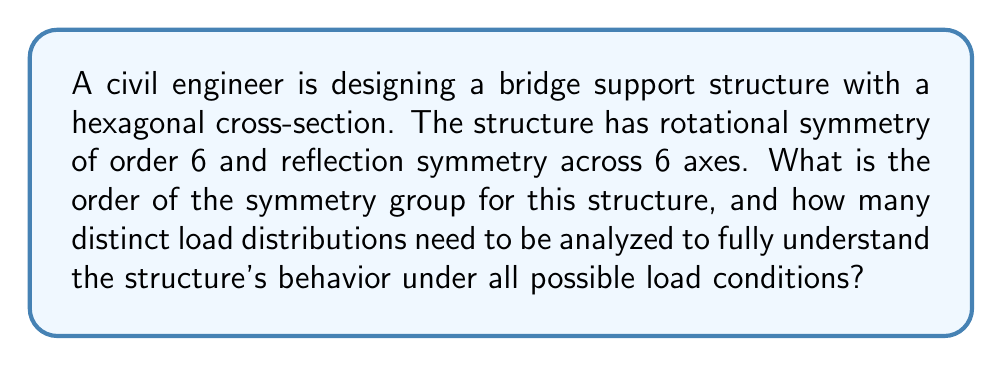Show me your answer to this math problem. To solve this problem, we need to understand the concept of symmetry groups and their application in structural design.

1. Identify the symmetry elements:
   - Rotational symmetry of order 6 (rotations by 60°, 120°, 180°, 240°, 300°, and 360°)
   - 6 reflection axes

2. Determine the symmetry group:
   The symmetry group of a regular hexagon is the dihedral group $D_6$.

3. Calculate the order of the symmetry group:
   The order of $D_6$ is given by the formula:
   $$|D_6| = 2n = 2 \cdot 6 = 12$$
   where $n$ is the number of sides of the polygon.

4. Analyze distinct load distributions:
   The number of distinct load distributions is equal to the number of symmetry classes, which can be calculated using Burnside's lemma:

   $$N = \frac{1}{|G|} \sum_{g \in G} |X^g|$$

   where:
   $N$ is the number of symmetry classes
   $|G|$ is the order of the symmetry group
   $X^g$ is the set of elements fixed by the symmetry operation $g$

5. Apply Burnside's lemma:
   - Identity element: fixes all 6 vertices
   - 5 rotations: fix no vertices
   - 6 reflections: each fixes 2 vertices

   $$N = \frac{1}{12} (6 + 0 + 0 + 0 + 0 + 0 + 2 + 2 + 2 + 2 + 2 + 2) = \frac{18}{12} = \frac{3}{2}$$

6. Interpret the result:
   Since we can't have a fractional number of load distributions, we round up to the nearest integer, which gives us 2 distinct load distributions to analyze.
Answer: The order of the symmetry group for the hexagonal structure is 12, and 2 distinct load distributions need to be analyzed to fully understand the structure's behavior under all possible load conditions. 